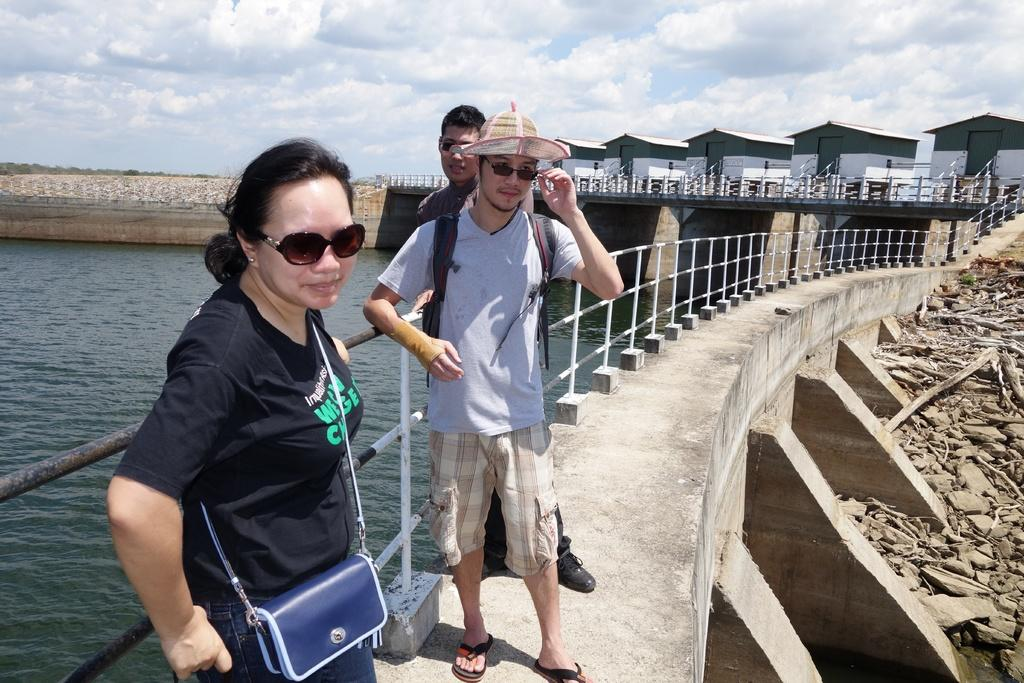How many people are in the image? There are three people in the image: two men and a woman. What are the people in the image doing? The people are standing. What can be seen in the foreground of the image? There is a path and water visible in the image. What is visible in the background of the image? There are houses and the sky visible in the background of the image. What type of rock is being used as a gate in the image? There is no rock or gate present in the image. 